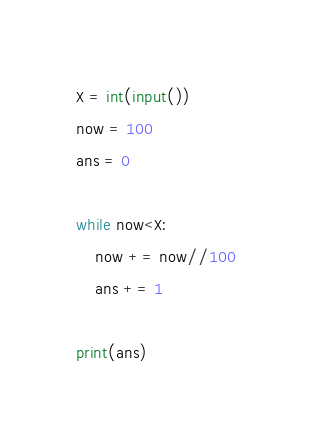Convert code to text. <code><loc_0><loc_0><loc_500><loc_500><_Python_>X = int(input())
now = 100
ans = 0

while now<X:
    now += now//100
    ans += 1

print(ans)</code> 